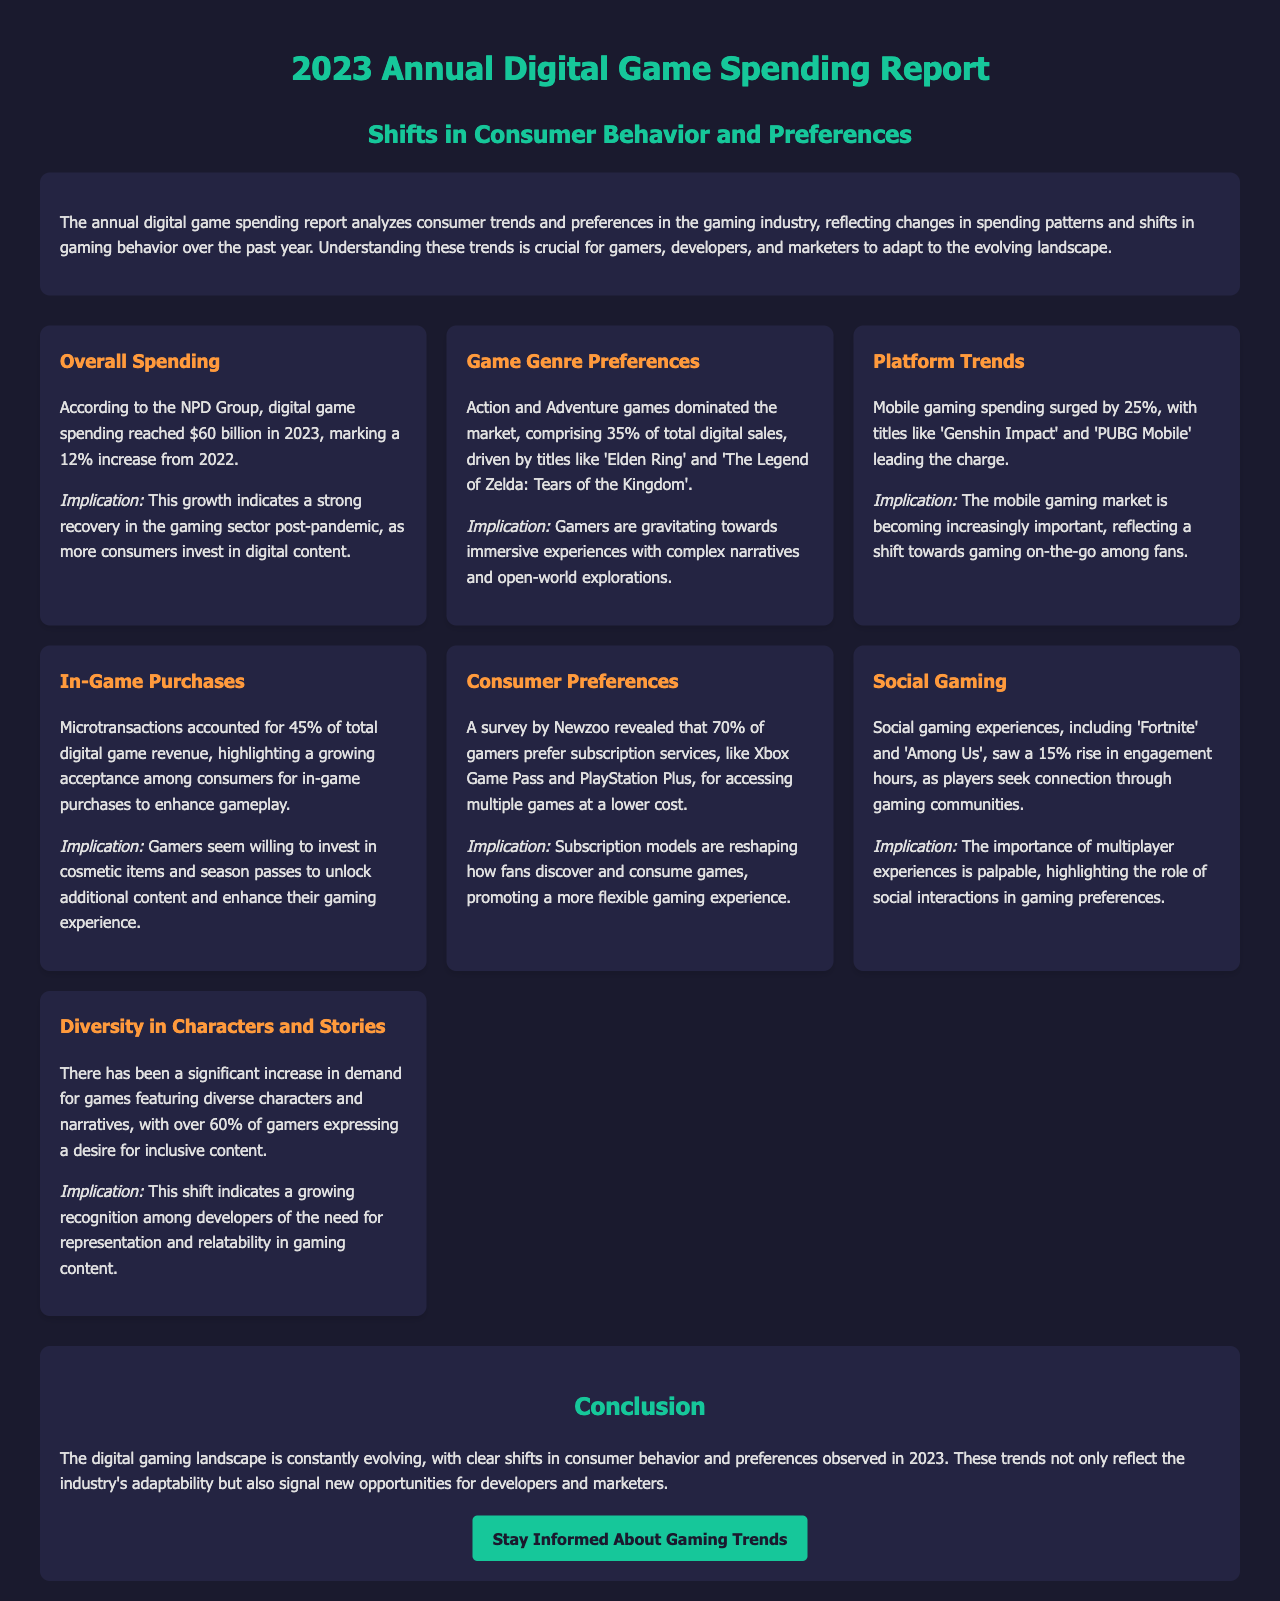what was the total digital game spending in 2023? The report states that digital game spending reached $60 billion in 2023.
Answer: $60 billion how much did mobile gaming spending increase? The document indicates that mobile gaming spending surged by 25%.
Answer: 25% what percentage of total digital sales did Action and Adventure games comprise? The report mentions that Action and Adventure games comprised 35% of total digital sales.
Answer: 35% what percentage of gamers prefer subscription services for accessing games? According to Newzoo, 70% of gamers prefer subscription services for accessing multiple games at a lower cost.
Answer: 70% which game was mentioned as a leading title in mobile gaming? The report highlights 'Genshin Impact' as a leading title in mobile gaming.
Answer: Genshin Impact what is the implication of increased in-game purchases? The growing acceptance of in-game purchases suggests that gamers are willing to invest in cosmetic items and season passes.
Answer: Gamers are willing to invest in cosmetic items how much did microtransactions account for in total digital game revenue? The report states that microtransactions accounted for 45% of total digital game revenue.
Answer: 45% what trend did social gaming experiences see in engagement hours? The document notes a 15% rise in engagement hours for social gaming experiences.
Answer: 15% what was a significant finding regarding character diversity in games? Over 60% of gamers expressed a desire for inclusive content featuring diverse characters and narratives.
Answer: 60% 